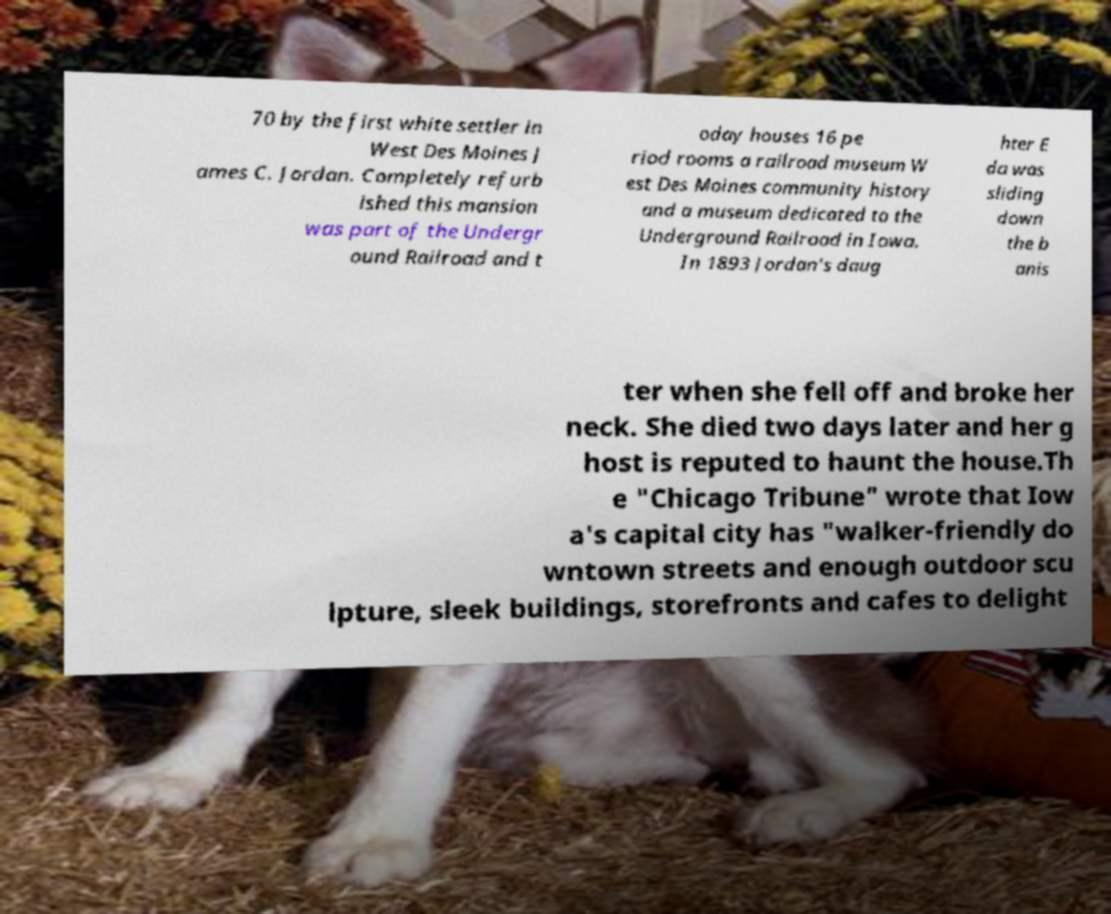Could you extract and type out the text from this image? 70 by the first white settler in West Des Moines J ames C. Jordan. Completely refurb ished this mansion was part of the Undergr ound Railroad and t oday houses 16 pe riod rooms a railroad museum W est Des Moines community history and a museum dedicated to the Underground Railroad in Iowa. In 1893 Jordan's daug hter E da was sliding down the b anis ter when she fell off and broke her neck. She died two days later and her g host is reputed to haunt the house.Th e "Chicago Tribune" wrote that Iow a's capital city has "walker-friendly do wntown streets and enough outdoor scu lpture, sleek buildings, storefronts and cafes to delight 